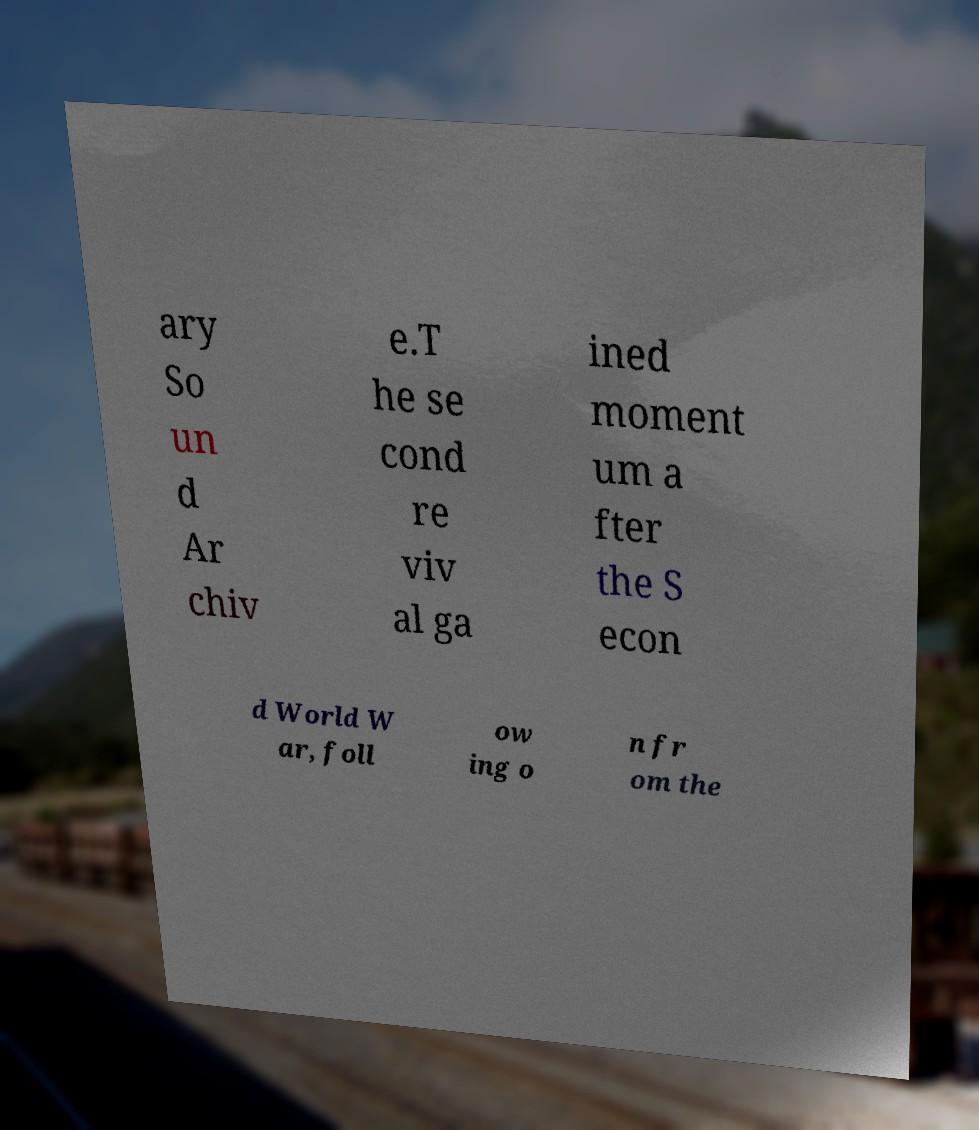Please read and relay the text visible in this image. What does it say? ary So un d Ar chiv e.T he se cond re viv al ga ined moment um a fter the S econ d World W ar, foll ow ing o n fr om the 